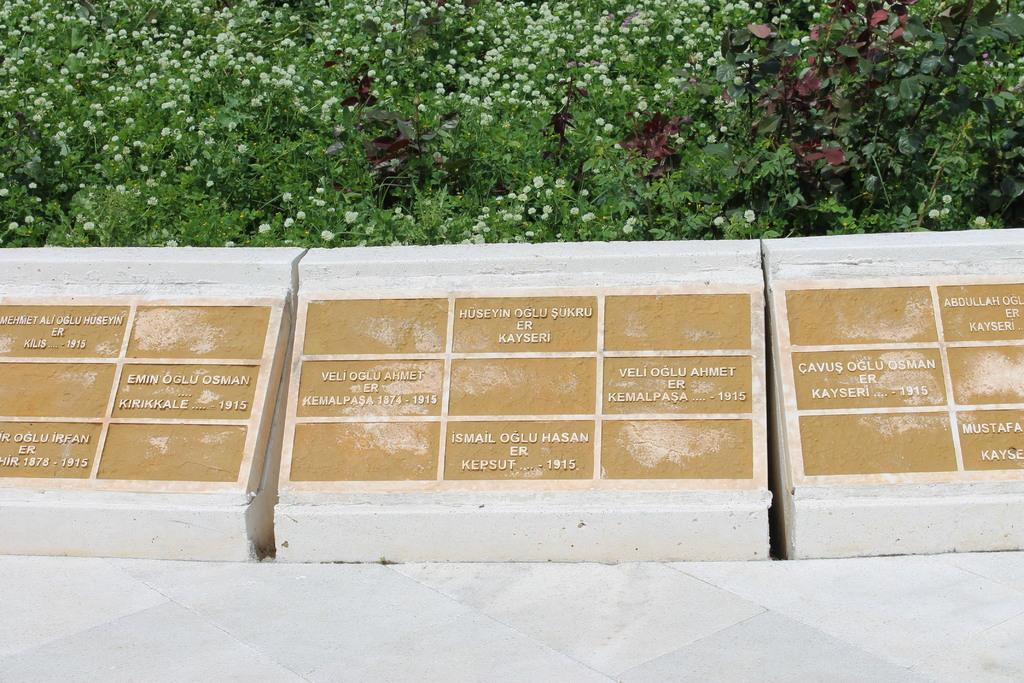What can be seen on the stones in the image? There are letters carved on stones in the image. What type of vegetation is visible in the background of the image? There are plants with tiny flowers in the background of the image. What is the surface on which the stones are placed in the image? There appears to be a floor at the bottom of the image. What type of railway is present in the image? There is no railway present in the image. Q: 